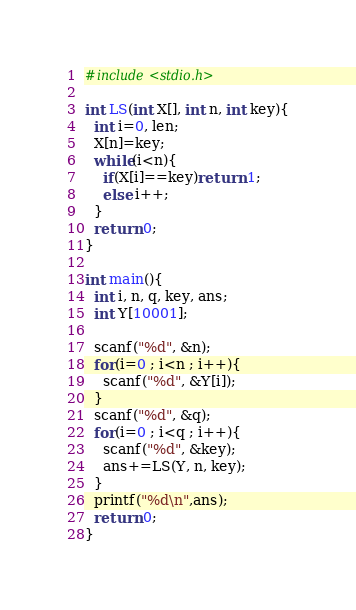Convert code to text. <code><loc_0><loc_0><loc_500><loc_500><_C++_>#include<stdio.h>

int LS(int X[], int n, int key){
  int i=0, len;
  X[n]=key;
  while(i<n){
    if(X[i]==key)return 1;
    else i++;
  }
  return 0;
}

int main(){
  int i, n, q, key, ans;
  int Y[10001];

  scanf("%d", &n);
  for(i=0 ; i<n ; i++){
    scanf("%d", &Y[i]);
  }
  scanf("%d", &q);
  for(i=0 ; i<q ; i++){
    scanf("%d", &key);
    ans+=LS(Y, n, key);
  }
  printf("%d\n",ans);
  return 0;
}
</code> 